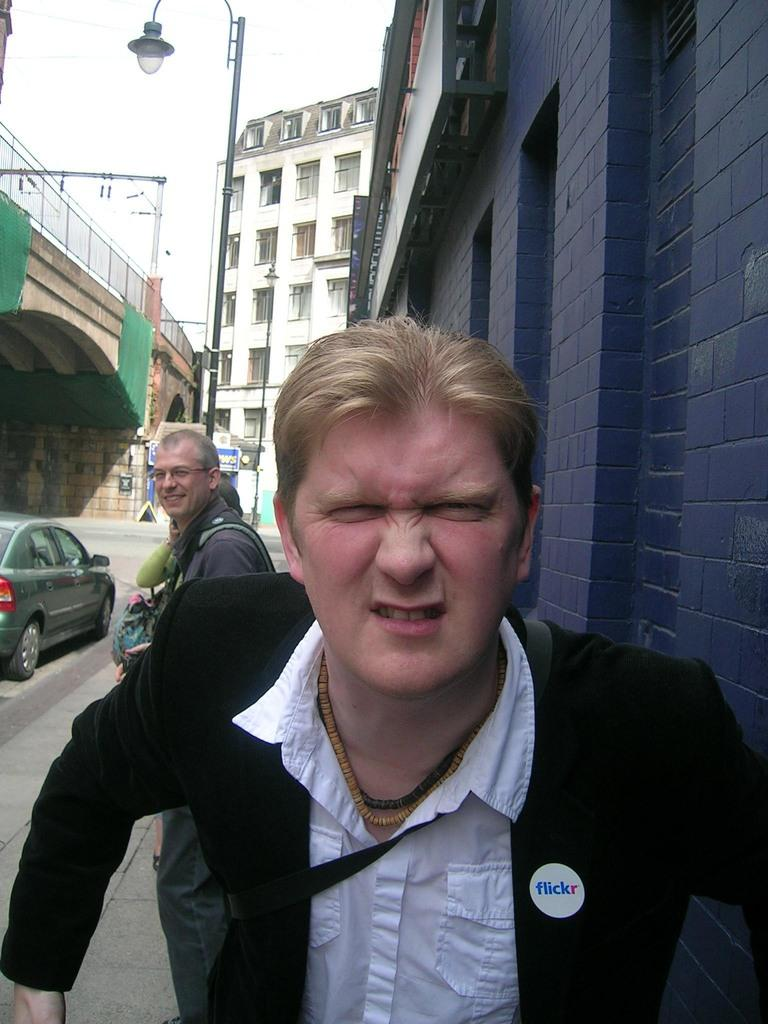Who or what can be seen in the image? There are people in the image. What is located on the left side of the image? There is a car on the left side of the image. Where is the car positioned in the image? The car is on the road. What can be seen in the background of the image? There are buildings, a fence, lights, and poles in the background of the image. What type of animal can be seen making a discovery in the image? There is no animal present in the image, nor is there any indication of a discovery being made. 